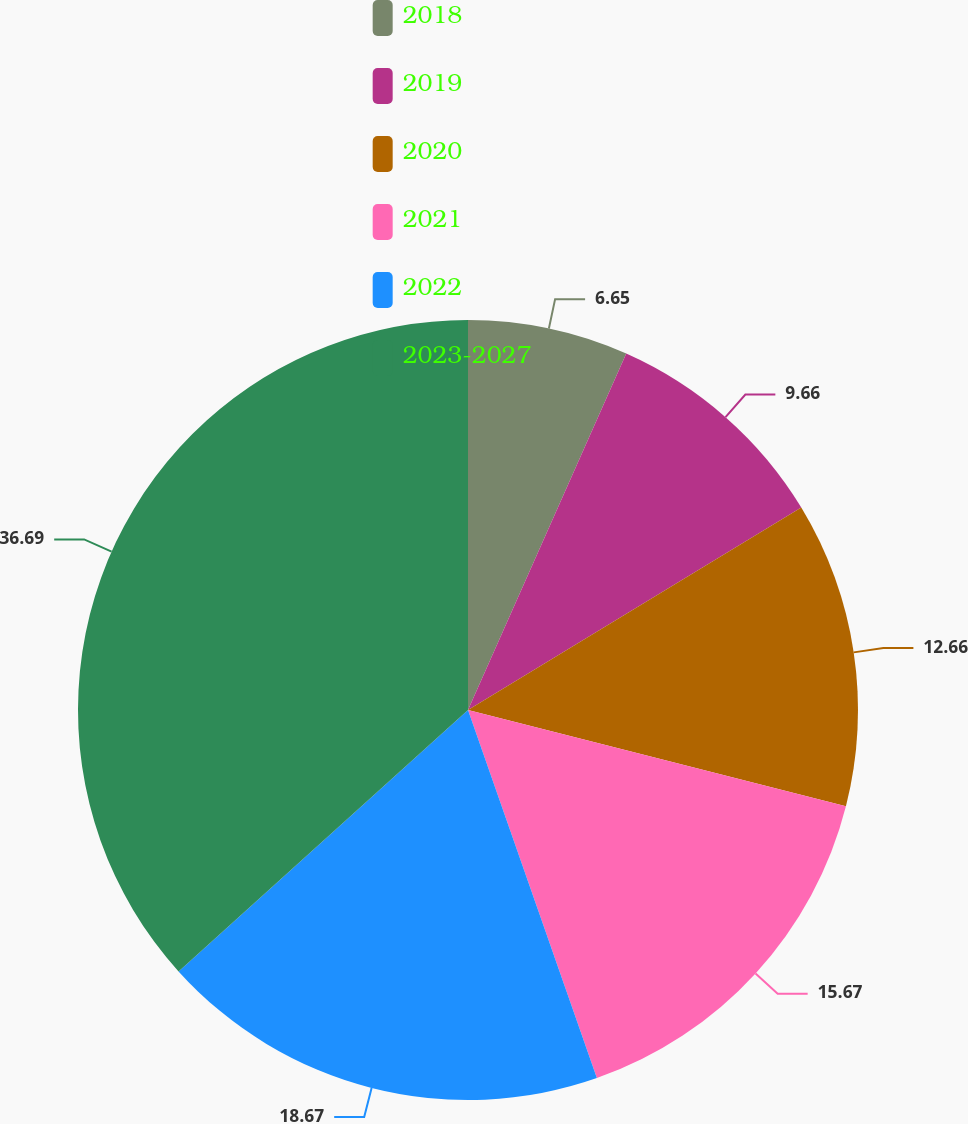Convert chart. <chart><loc_0><loc_0><loc_500><loc_500><pie_chart><fcel>2018<fcel>2019<fcel>2020<fcel>2021<fcel>2022<fcel>2023-2027<nl><fcel>6.65%<fcel>9.66%<fcel>12.66%<fcel>15.67%<fcel>18.67%<fcel>36.69%<nl></chart> 